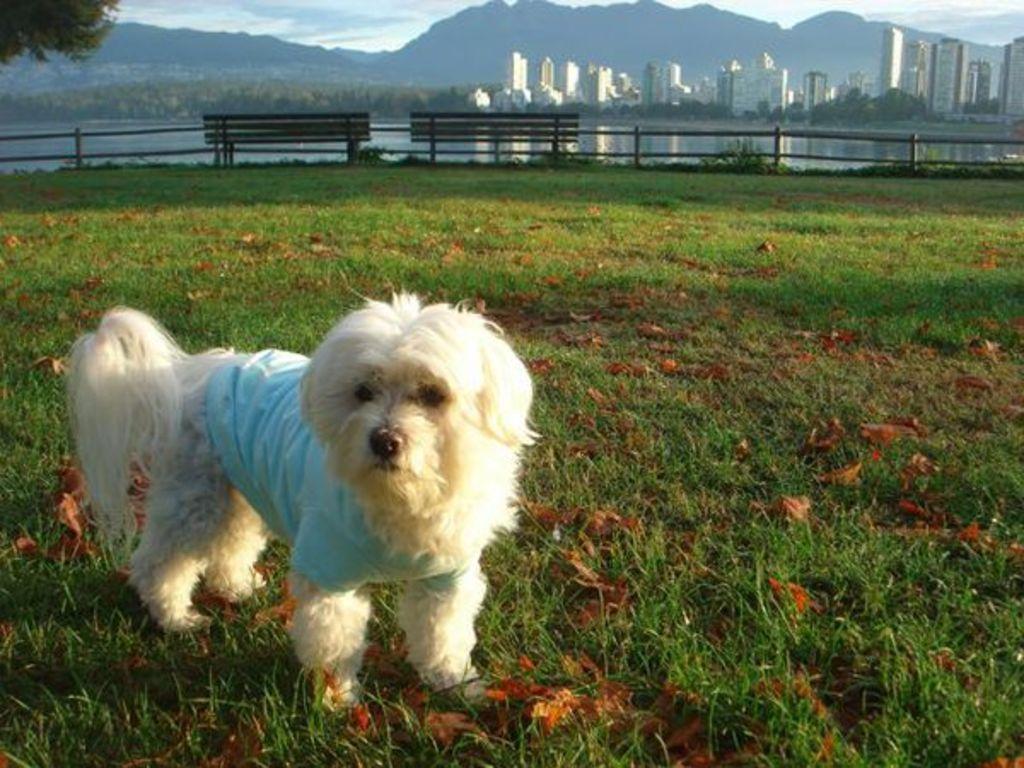Can you describe this image briefly? In the foreground, I can see a dog on grass. In the background, I can see a fence, benches, water, trees, buildings, towers, mountains and the sky. This picture is taken during a sunny day. 